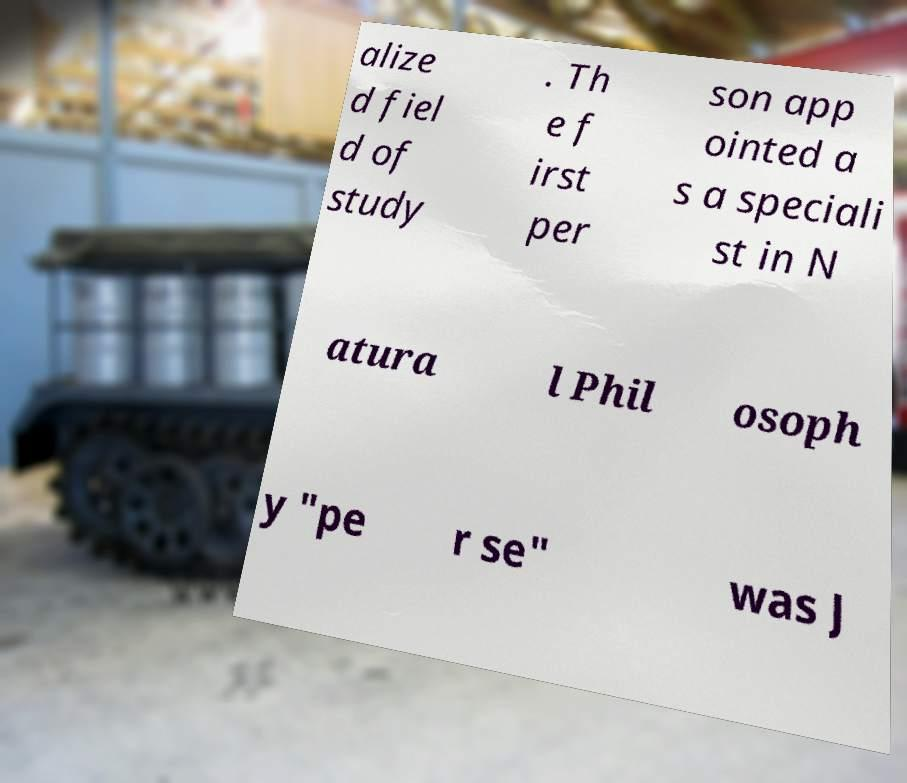Please identify and transcribe the text found in this image. alize d fiel d of study . Th e f irst per son app ointed a s a speciali st in N atura l Phil osoph y "pe r se" was J 